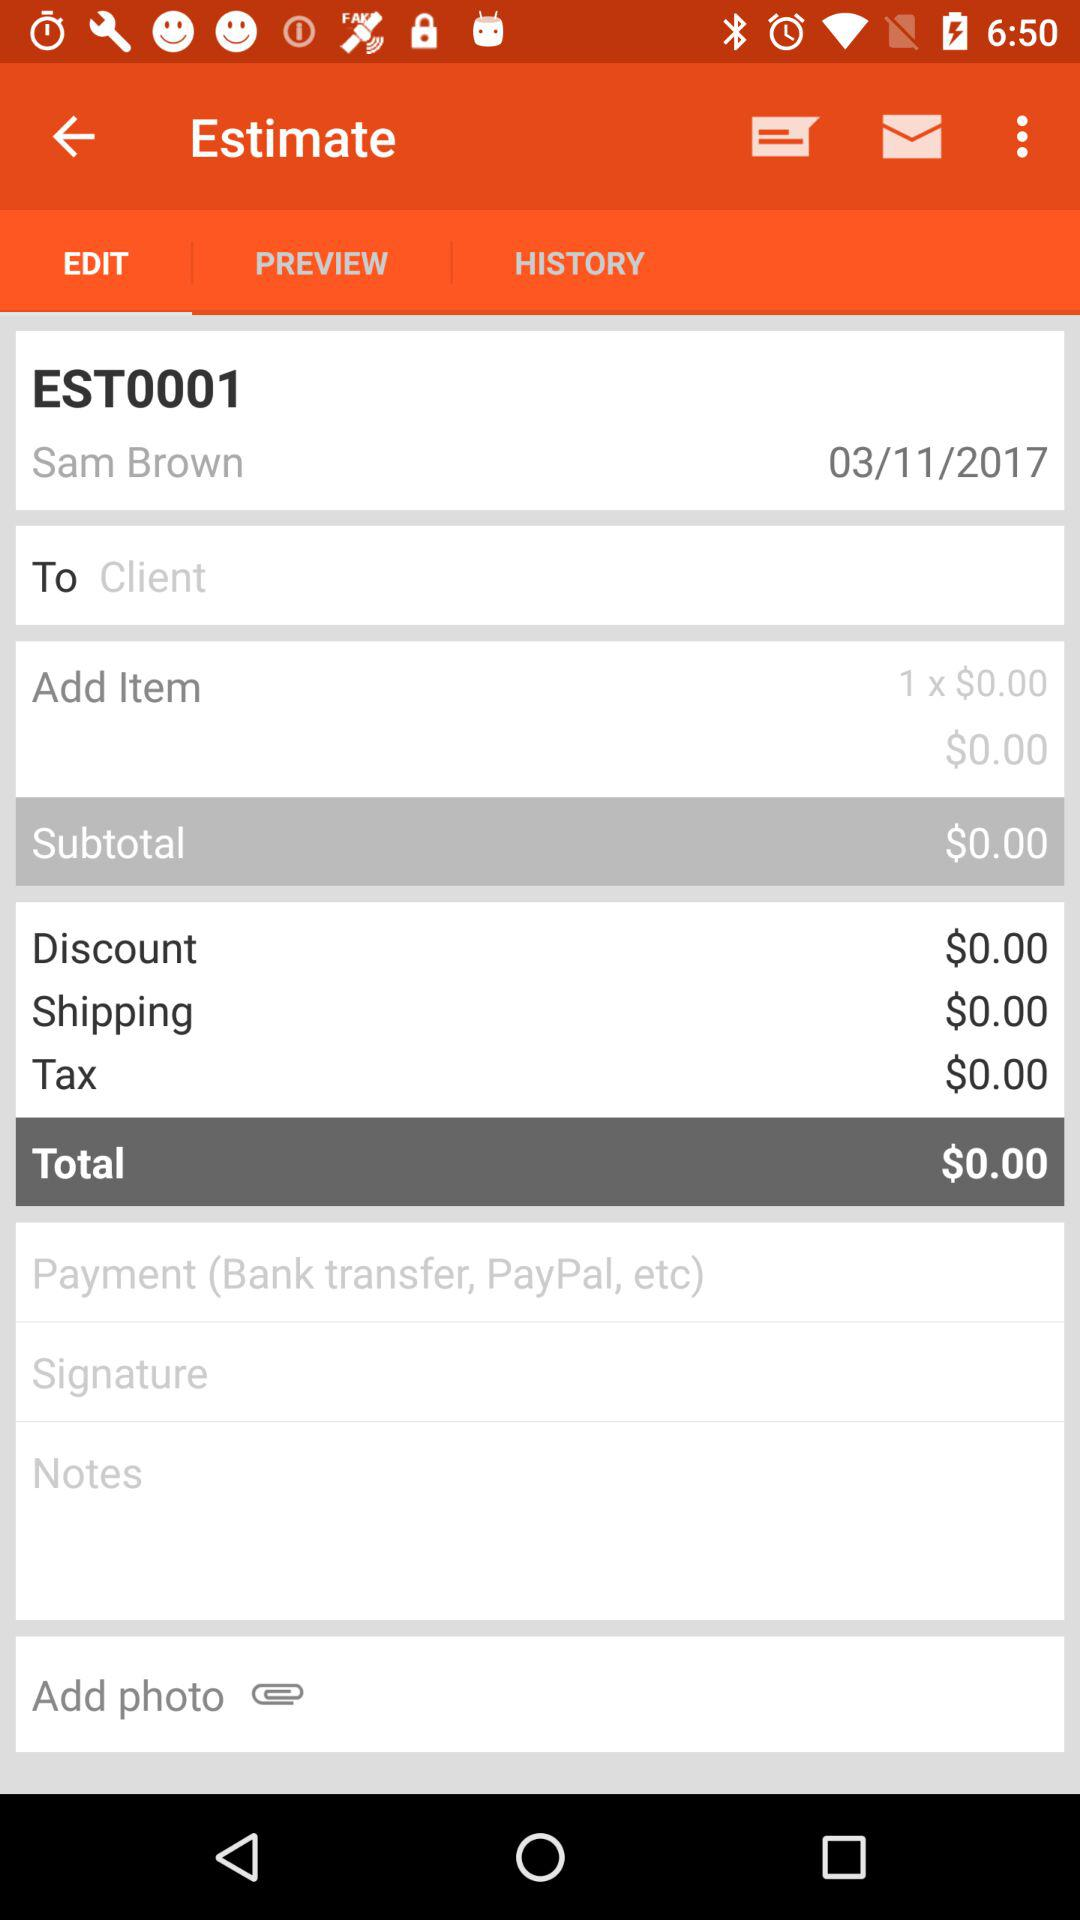What is the invoice number? The invoice number is EST0001. 